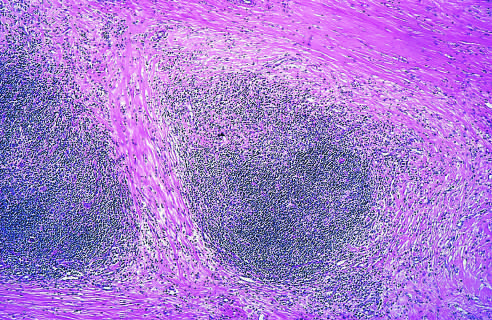what shows well-defined bands of pink, acellular collagen that have subdivided the tumor cells into nodules?
Answer the question using a single word or phrase. A low-power view 